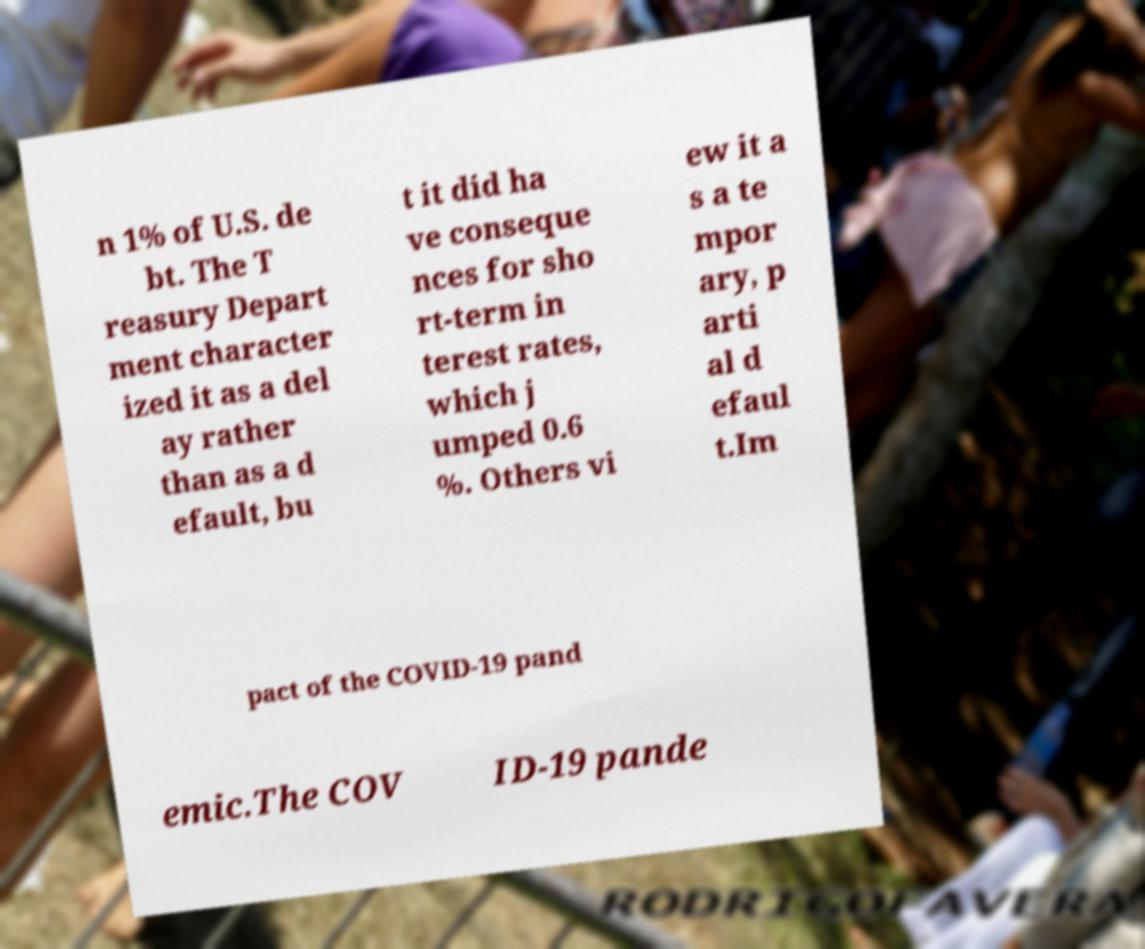Can you accurately transcribe the text from the provided image for me? n 1% of U.S. de bt. The T reasury Depart ment character ized it as a del ay rather than as a d efault, bu t it did ha ve conseque nces for sho rt-term in terest rates, which j umped 0.6 %. Others vi ew it a s a te mpor ary, p arti al d efaul t.Im pact of the COVID-19 pand emic.The COV ID-19 pande 